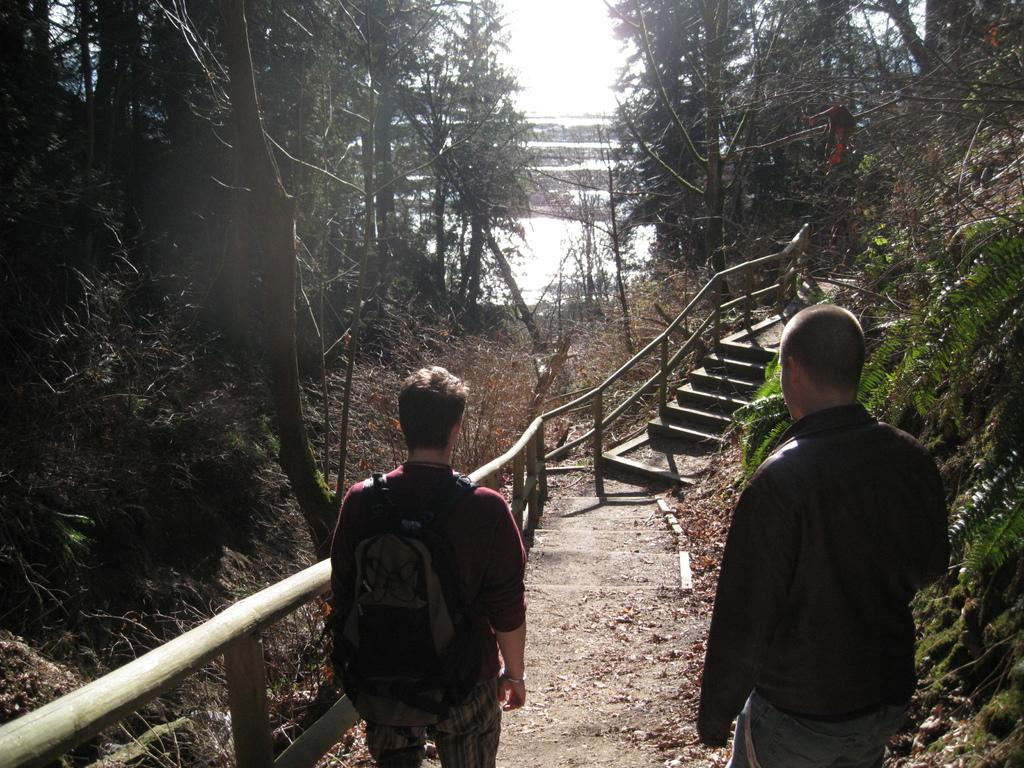How many people are in the image? There are two persons standing in the image. What is located beside the persons? There is a fence beside the persons. What type of vegetation is present on either side of the persons? There are trees on either side of the persons. What can be seen in the background of the image? There is water visible in the background of the image. What type of banana is hanging from the tree on the left side of the image? There is no banana present in the image; only trees are mentioned. 